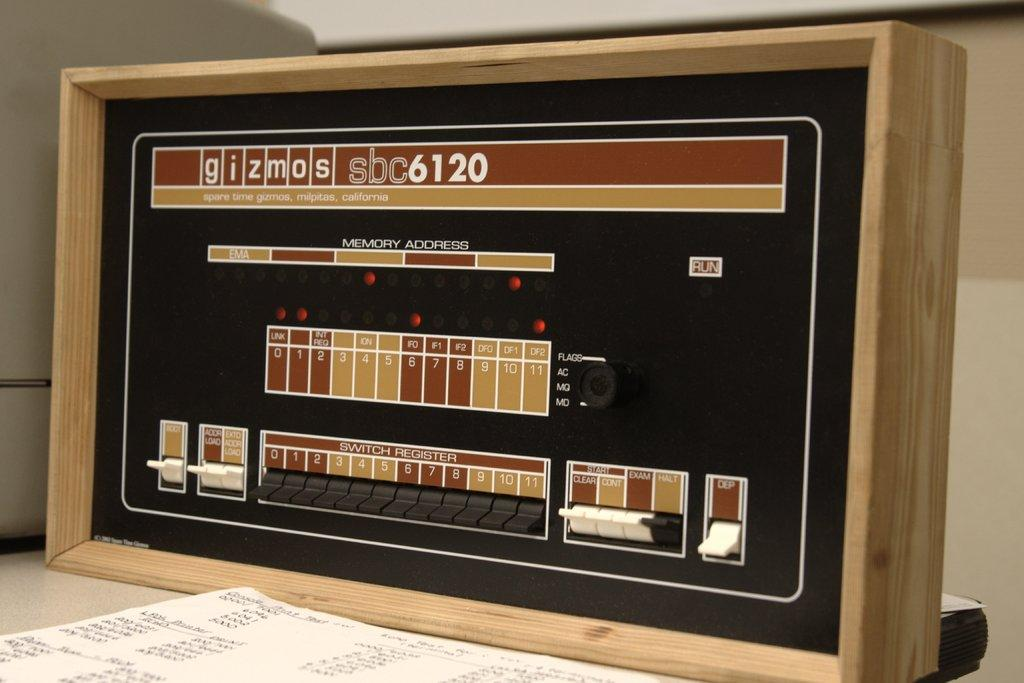What is the main object in the image? There is an object in the image, but its specific nature is not mentioned in the facts. What type of material is present in the image? There is paper in the image. What can be used to process or manipulate information in the image? There is a device in the image. On what surface are these items placed? All of these items are placed on a platform. What type of flesh can be seen on the bed in the image? There is no flesh or bed present in the image; the facts mention an object, paper, a device, and a platform. 